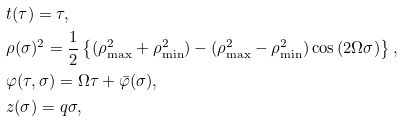<formula> <loc_0><loc_0><loc_500><loc_500>& t ( \tau ) = \tau , \\ & { \rho } ( \sigma ) ^ { 2 } = \frac { 1 } { 2 } \left \{ ( \rho _ { \max } ^ { 2 } + \rho _ { \min } ^ { 2 } ) - ( \rho _ { \max } ^ { 2 } - \rho _ { \min } ^ { 2 } ) \cos \left ( 2 \Omega \sigma \right ) \right \} , \\ & \varphi ( \tau , \sigma ) = \Omega \tau + \bar { \varphi } ( \sigma ) , \\ & z ( \sigma ) = q \sigma ,</formula> 